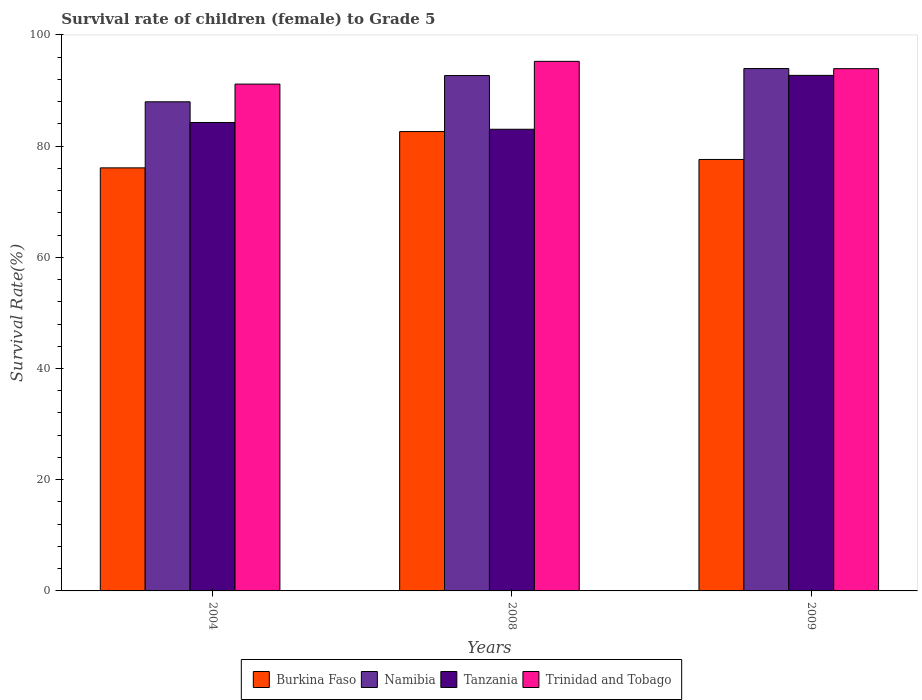How many different coloured bars are there?
Make the answer very short. 4. How many groups of bars are there?
Your answer should be very brief. 3. Are the number of bars per tick equal to the number of legend labels?
Offer a very short reply. Yes. How many bars are there on the 2nd tick from the left?
Your answer should be compact. 4. How many bars are there on the 1st tick from the right?
Offer a terse response. 4. In how many cases, is the number of bars for a given year not equal to the number of legend labels?
Your answer should be very brief. 0. What is the survival rate of female children to grade 5 in Trinidad and Tobago in 2008?
Your answer should be very brief. 95.24. Across all years, what is the maximum survival rate of female children to grade 5 in Burkina Faso?
Make the answer very short. 82.62. Across all years, what is the minimum survival rate of female children to grade 5 in Trinidad and Tobago?
Offer a very short reply. 91.15. In which year was the survival rate of female children to grade 5 in Trinidad and Tobago maximum?
Your response must be concise. 2008. In which year was the survival rate of female children to grade 5 in Trinidad and Tobago minimum?
Your answer should be very brief. 2004. What is the total survival rate of female children to grade 5 in Burkina Faso in the graph?
Provide a succinct answer. 236.31. What is the difference between the survival rate of female children to grade 5 in Tanzania in 2004 and that in 2009?
Make the answer very short. -8.47. What is the difference between the survival rate of female children to grade 5 in Burkina Faso in 2008 and the survival rate of female children to grade 5 in Trinidad and Tobago in 2009?
Provide a succinct answer. -11.31. What is the average survival rate of female children to grade 5 in Tanzania per year?
Offer a very short reply. 86.67. In the year 2004, what is the difference between the survival rate of female children to grade 5 in Tanzania and survival rate of female children to grade 5 in Trinidad and Tobago?
Your response must be concise. -6.9. What is the ratio of the survival rate of female children to grade 5 in Trinidad and Tobago in 2004 to that in 2008?
Your response must be concise. 0.96. What is the difference between the highest and the second highest survival rate of female children to grade 5 in Namibia?
Provide a short and direct response. 1.26. What is the difference between the highest and the lowest survival rate of female children to grade 5 in Namibia?
Provide a short and direct response. 5.98. In how many years, is the survival rate of female children to grade 5 in Namibia greater than the average survival rate of female children to grade 5 in Namibia taken over all years?
Provide a succinct answer. 2. What does the 3rd bar from the left in 2008 represents?
Provide a succinct answer. Tanzania. What does the 1st bar from the right in 2004 represents?
Provide a short and direct response. Trinidad and Tobago. Is it the case that in every year, the sum of the survival rate of female children to grade 5 in Trinidad and Tobago and survival rate of female children to grade 5 in Burkina Faso is greater than the survival rate of female children to grade 5 in Tanzania?
Offer a terse response. Yes. How many years are there in the graph?
Keep it short and to the point. 3. What is the difference between two consecutive major ticks on the Y-axis?
Your response must be concise. 20. Are the values on the major ticks of Y-axis written in scientific E-notation?
Provide a short and direct response. No. Does the graph contain grids?
Offer a terse response. No. What is the title of the graph?
Your answer should be very brief. Survival rate of children (female) to Grade 5. Does "Pakistan" appear as one of the legend labels in the graph?
Your answer should be very brief. No. What is the label or title of the X-axis?
Offer a terse response. Years. What is the label or title of the Y-axis?
Offer a very short reply. Survival Rate(%). What is the Survival Rate(%) in Burkina Faso in 2004?
Your answer should be very brief. 76.09. What is the Survival Rate(%) in Namibia in 2004?
Provide a succinct answer. 87.97. What is the Survival Rate(%) in Tanzania in 2004?
Your answer should be compact. 84.25. What is the Survival Rate(%) in Trinidad and Tobago in 2004?
Offer a very short reply. 91.15. What is the Survival Rate(%) of Burkina Faso in 2008?
Keep it short and to the point. 82.62. What is the Survival Rate(%) of Namibia in 2008?
Provide a short and direct response. 92.69. What is the Survival Rate(%) of Tanzania in 2008?
Your answer should be compact. 83.03. What is the Survival Rate(%) in Trinidad and Tobago in 2008?
Offer a terse response. 95.24. What is the Survival Rate(%) in Burkina Faso in 2009?
Make the answer very short. 77.6. What is the Survival Rate(%) of Namibia in 2009?
Offer a very short reply. 93.95. What is the Survival Rate(%) of Tanzania in 2009?
Keep it short and to the point. 92.72. What is the Survival Rate(%) in Trinidad and Tobago in 2009?
Ensure brevity in your answer.  93.93. Across all years, what is the maximum Survival Rate(%) of Burkina Faso?
Make the answer very short. 82.62. Across all years, what is the maximum Survival Rate(%) of Namibia?
Give a very brief answer. 93.95. Across all years, what is the maximum Survival Rate(%) in Tanzania?
Make the answer very short. 92.72. Across all years, what is the maximum Survival Rate(%) of Trinidad and Tobago?
Make the answer very short. 95.24. Across all years, what is the minimum Survival Rate(%) in Burkina Faso?
Your answer should be very brief. 76.09. Across all years, what is the minimum Survival Rate(%) in Namibia?
Provide a succinct answer. 87.97. Across all years, what is the minimum Survival Rate(%) in Tanzania?
Provide a short and direct response. 83.03. Across all years, what is the minimum Survival Rate(%) of Trinidad and Tobago?
Your response must be concise. 91.15. What is the total Survival Rate(%) of Burkina Faso in the graph?
Offer a very short reply. 236.31. What is the total Survival Rate(%) in Namibia in the graph?
Offer a very short reply. 274.61. What is the total Survival Rate(%) in Tanzania in the graph?
Your answer should be compact. 260.01. What is the total Survival Rate(%) in Trinidad and Tobago in the graph?
Your answer should be compact. 280.33. What is the difference between the Survival Rate(%) of Burkina Faso in 2004 and that in 2008?
Give a very brief answer. -6.53. What is the difference between the Survival Rate(%) in Namibia in 2004 and that in 2008?
Give a very brief answer. -4.72. What is the difference between the Survival Rate(%) in Tanzania in 2004 and that in 2008?
Provide a short and direct response. 1.22. What is the difference between the Survival Rate(%) in Trinidad and Tobago in 2004 and that in 2008?
Your response must be concise. -4.09. What is the difference between the Survival Rate(%) of Burkina Faso in 2004 and that in 2009?
Ensure brevity in your answer.  -1.51. What is the difference between the Survival Rate(%) of Namibia in 2004 and that in 2009?
Offer a very short reply. -5.98. What is the difference between the Survival Rate(%) in Tanzania in 2004 and that in 2009?
Make the answer very short. -8.47. What is the difference between the Survival Rate(%) of Trinidad and Tobago in 2004 and that in 2009?
Offer a very short reply. -2.78. What is the difference between the Survival Rate(%) of Burkina Faso in 2008 and that in 2009?
Provide a succinct answer. 5.02. What is the difference between the Survival Rate(%) of Namibia in 2008 and that in 2009?
Your answer should be compact. -1.26. What is the difference between the Survival Rate(%) in Tanzania in 2008 and that in 2009?
Give a very brief answer. -9.69. What is the difference between the Survival Rate(%) in Trinidad and Tobago in 2008 and that in 2009?
Make the answer very short. 1.31. What is the difference between the Survival Rate(%) of Burkina Faso in 2004 and the Survival Rate(%) of Namibia in 2008?
Ensure brevity in your answer.  -16.6. What is the difference between the Survival Rate(%) of Burkina Faso in 2004 and the Survival Rate(%) of Tanzania in 2008?
Your answer should be very brief. -6.94. What is the difference between the Survival Rate(%) of Burkina Faso in 2004 and the Survival Rate(%) of Trinidad and Tobago in 2008?
Provide a succinct answer. -19.16. What is the difference between the Survival Rate(%) of Namibia in 2004 and the Survival Rate(%) of Tanzania in 2008?
Your response must be concise. 4.94. What is the difference between the Survival Rate(%) in Namibia in 2004 and the Survival Rate(%) in Trinidad and Tobago in 2008?
Make the answer very short. -7.28. What is the difference between the Survival Rate(%) of Tanzania in 2004 and the Survival Rate(%) of Trinidad and Tobago in 2008?
Provide a short and direct response. -10.99. What is the difference between the Survival Rate(%) of Burkina Faso in 2004 and the Survival Rate(%) of Namibia in 2009?
Offer a terse response. -17.86. What is the difference between the Survival Rate(%) in Burkina Faso in 2004 and the Survival Rate(%) in Tanzania in 2009?
Offer a terse response. -16.63. What is the difference between the Survival Rate(%) in Burkina Faso in 2004 and the Survival Rate(%) in Trinidad and Tobago in 2009?
Make the answer very short. -17.84. What is the difference between the Survival Rate(%) of Namibia in 2004 and the Survival Rate(%) of Tanzania in 2009?
Make the answer very short. -4.75. What is the difference between the Survival Rate(%) of Namibia in 2004 and the Survival Rate(%) of Trinidad and Tobago in 2009?
Keep it short and to the point. -5.96. What is the difference between the Survival Rate(%) of Tanzania in 2004 and the Survival Rate(%) of Trinidad and Tobago in 2009?
Give a very brief answer. -9.68. What is the difference between the Survival Rate(%) of Burkina Faso in 2008 and the Survival Rate(%) of Namibia in 2009?
Your response must be concise. -11.34. What is the difference between the Survival Rate(%) in Burkina Faso in 2008 and the Survival Rate(%) in Tanzania in 2009?
Make the answer very short. -10.11. What is the difference between the Survival Rate(%) in Burkina Faso in 2008 and the Survival Rate(%) in Trinidad and Tobago in 2009?
Your answer should be very brief. -11.31. What is the difference between the Survival Rate(%) in Namibia in 2008 and the Survival Rate(%) in Tanzania in 2009?
Offer a terse response. -0.03. What is the difference between the Survival Rate(%) of Namibia in 2008 and the Survival Rate(%) of Trinidad and Tobago in 2009?
Your answer should be very brief. -1.24. What is the difference between the Survival Rate(%) of Tanzania in 2008 and the Survival Rate(%) of Trinidad and Tobago in 2009?
Make the answer very short. -10.9. What is the average Survival Rate(%) in Burkina Faso per year?
Offer a very short reply. 78.77. What is the average Survival Rate(%) in Namibia per year?
Give a very brief answer. 91.54. What is the average Survival Rate(%) of Tanzania per year?
Your answer should be compact. 86.67. What is the average Survival Rate(%) in Trinidad and Tobago per year?
Your response must be concise. 93.44. In the year 2004, what is the difference between the Survival Rate(%) in Burkina Faso and Survival Rate(%) in Namibia?
Offer a very short reply. -11.88. In the year 2004, what is the difference between the Survival Rate(%) of Burkina Faso and Survival Rate(%) of Tanzania?
Your answer should be very brief. -8.16. In the year 2004, what is the difference between the Survival Rate(%) of Burkina Faso and Survival Rate(%) of Trinidad and Tobago?
Your answer should be very brief. -15.06. In the year 2004, what is the difference between the Survival Rate(%) in Namibia and Survival Rate(%) in Tanzania?
Offer a terse response. 3.72. In the year 2004, what is the difference between the Survival Rate(%) of Namibia and Survival Rate(%) of Trinidad and Tobago?
Your answer should be compact. -3.19. In the year 2004, what is the difference between the Survival Rate(%) of Tanzania and Survival Rate(%) of Trinidad and Tobago?
Your answer should be compact. -6.9. In the year 2008, what is the difference between the Survival Rate(%) of Burkina Faso and Survival Rate(%) of Namibia?
Your answer should be very brief. -10.07. In the year 2008, what is the difference between the Survival Rate(%) of Burkina Faso and Survival Rate(%) of Tanzania?
Keep it short and to the point. -0.42. In the year 2008, what is the difference between the Survival Rate(%) in Burkina Faso and Survival Rate(%) in Trinidad and Tobago?
Your answer should be very brief. -12.63. In the year 2008, what is the difference between the Survival Rate(%) in Namibia and Survival Rate(%) in Tanzania?
Give a very brief answer. 9.66. In the year 2008, what is the difference between the Survival Rate(%) of Namibia and Survival Rate(%) of Trinidad and Tobago?
Offer a very short reply. -2.55. In the year 2008, what is the difference between the Survival Rate(%) of Tanzania and Survival Rate(%) of Trinidad and Tobago?
Make the answer very short. -12.21. In the year 2009, what is the difference between the Survival Rate(%) of Burkina Faso and Survival Rate(%) of Namibia?
Ensure brevity in your answer.  -16.35. In the year 2009, what is the difference between the Survival Rate(%) of Burkina Faso and Survival Rate(%) of Tanzania?
Give a very brief answer. -15.12. In the year 2009, what is the difference between the Survival Rate(%) in Burkina Faso and Survival Rate(%) in Trinidad and Tobago?
Give a very brief answer. -16.33. In the year 2009, what is the difference between the Survival Rate(%) of Namibia and Survival Rate(%) of Tanzania?
Provide a succinct answer. 1.23. In the year 2009, what is the difference between the Survival Rate(%) in Namibia and Survival Rate(%) in Trinidad and Tobago?
Provide a succinct answer. 0.02. In the year 2009, what is the difference between the Survival Rate(%) in Tanzania and Survival Rate(%) in Trinidad and Tobago?
Give a very brief answer. -1.21. What is the ratio of the Survival Rate(%) of Burkina Faso in 2004 to that in 2008?
Provide a succinct answer. 0.92. What is the ratio of the Survival Rate(%) of Namibia in 2004 to that in 2008?
Offer a very short reply. 0.95. What is the ratio of the Survival Rate(%) in Tanzania in 2004 to that in 2008?
Your answer should be compact. 1.01. What is the ratio of the Survival Rate(%) in Trinidad and Tobago in 2004 to that in 2008?
Your answer should be compact. 0.96. What is the ratio of the Survival Rate(%) of Burkina Faso in 2004 to that in 2009?
Your response must be concise. 0.98. What is the ratio of the Survival Rate(%) in Namibia in 2004 to that in 2009?
Provide a succinct answer. 0.94. What is the ratio of the Survival Rate(%) of Tanzania in 2004 to that in 2009?
Give a very brief answer. 0.91. What is the ratio of the Survival Rate(%) of Trinidad and Tobago in 2004 to that in 2009?
Your response must be concise. 0.97. What is the ratio of the Survival Rate(%) of Burkina Faso in 2008 to that in 2009?
Your answer should be very brief. 1.06. What is the ratio of the Survival Rate(%) of Namibia in 2008 to that in 2009?
Make the answer very short. 0.99. What is the ratio of the Survival Rate(%) of Tanzania in 2008 to that in 2009?
Make the answer very short. 0.9. What is the difference between the highest and the second highest Survival Rate(%) of Burkina Faso?
Provide a succinct answer. 5.02. What is the difference between the highest and the second highest Survival Rate(%) of Namibia?
Give a very brief answer. 1.26. What is the difference between the highest and the second highest Survival Rate(%) in Tanzania?
Your answer should be compact. 8.47. What is the difference between the highest and the second highest Survival Rate(%) in Trinidad and Tobago?
Offer a very short reply. 1.31. What is the difference between the highest and the lowest Survival Rate(%) in Burkina Faso?
Give a very brief answer. 6.53. What is the difference between the highest and the lowest Survival Rate(%) of Namibia?
Make the answer very short. 5.98. What is the difference between the highest and the lowest Survival Rate(%) of Tanzania?
Your answer should be very brief. 9.69. What is the difference between the highest and the lowest Survival Rate(%) of Trinidad and Tobago?
Your answer should be very brief. 4.09. 